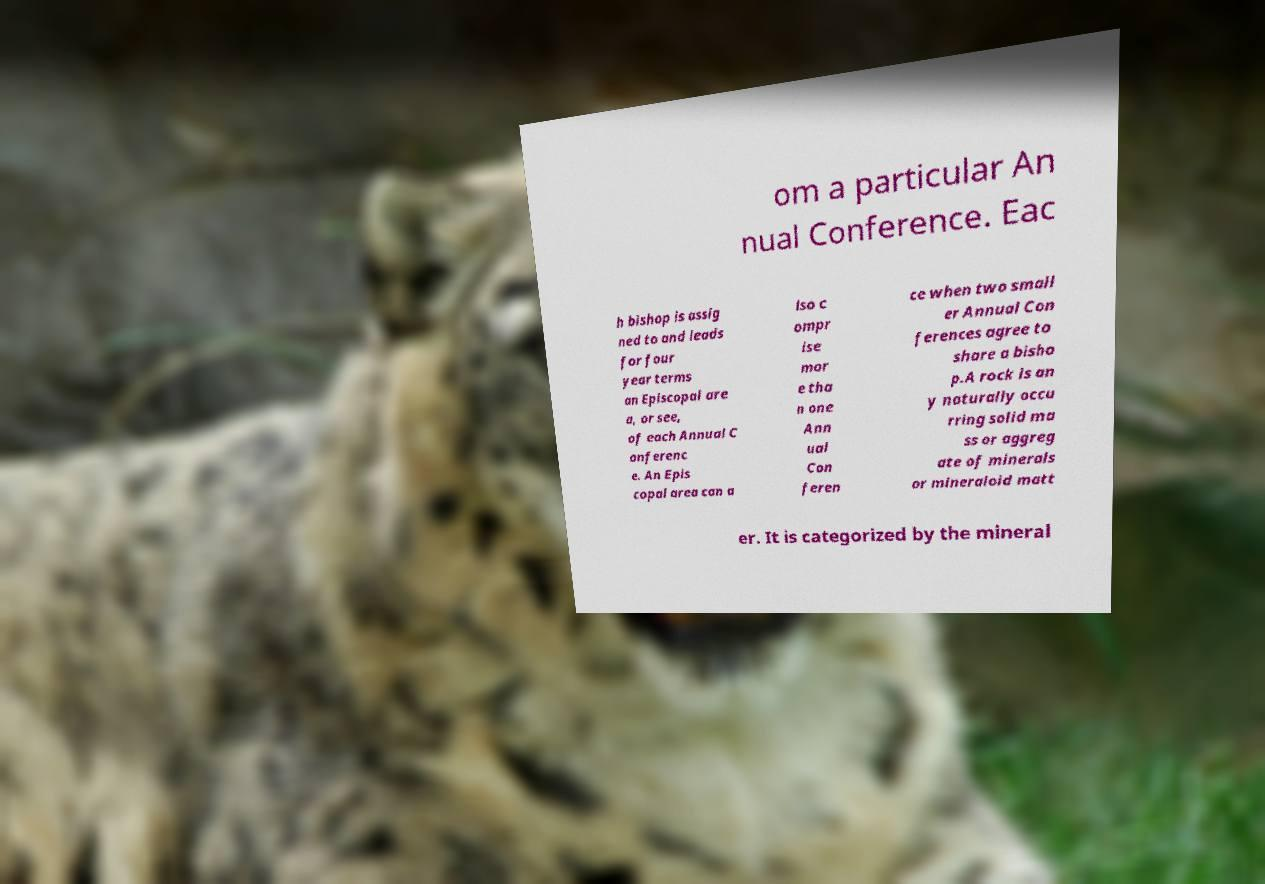I need the written content from this picture converted into text. Can you do that? om a particular An nual Conference. Eac h bishop is assig ned to and leads for four year terms an Episcopal are a, or see, of each Annual C onferenc e. An Epis copal area can a lso c ompr ise mor e tha n one Ann ual Con feren ce when two small er Annual Con ferences agree to share a bisho p.A rock is an y naturally occu rring solid ma ss or aggreg ate of minerals or mineraloid matt er. It is categorized by the mineral 